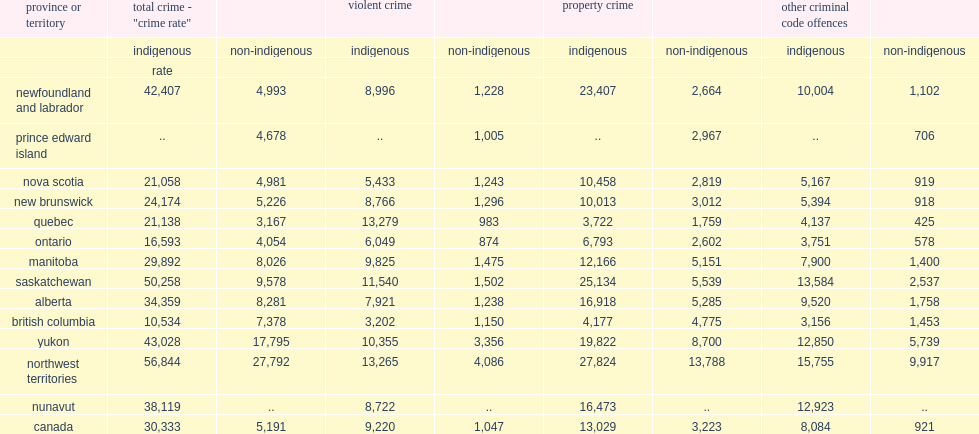What is the number of an overall crime rate police serving majority indigenous populations reported in 2018? 30333.0. What is the number of an overall crime rate police serving majority non-indigenous populations reported in 2018? 5191.0. 